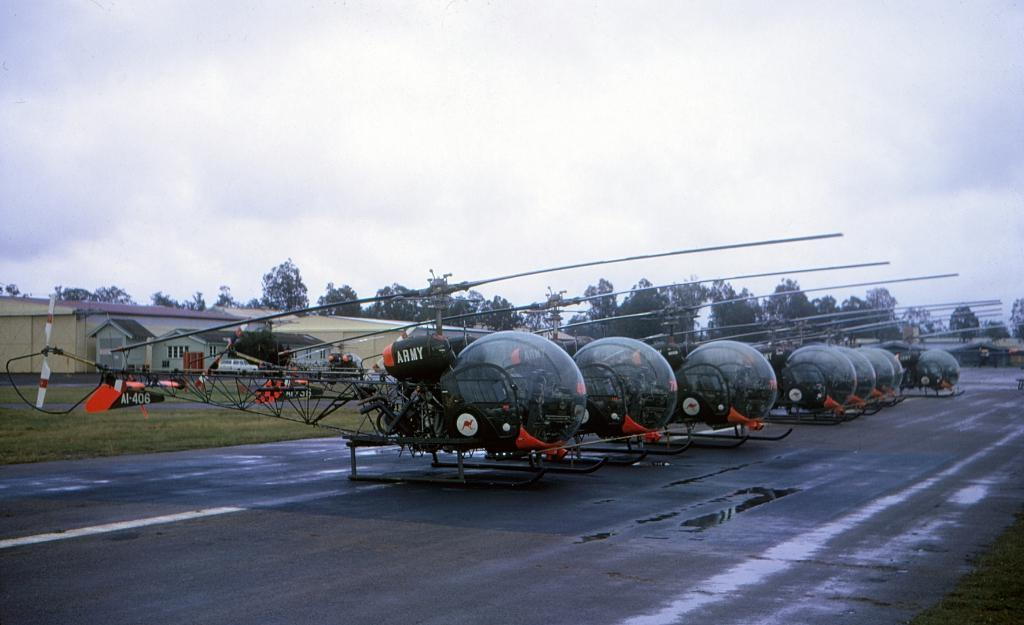What can be seen on the runway in the image? There are helicopters on the runway. What is visible in the background of the image? There are houses, trees, vehicles, and the sky visible in the background. Can you describe the type of vehicles in the background? The provided facts do not specify the type of vehicles in the background. What type of cloth is being used to cover the helicopter blades in the image? There is no cloth or helicopter blades visible in the image. 